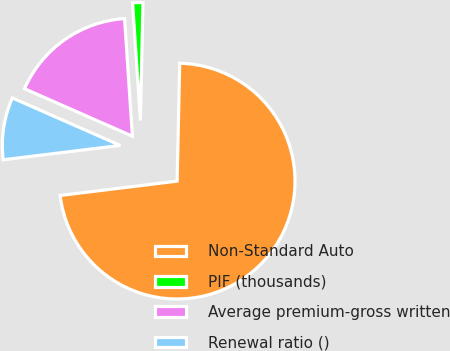Convert chart to OTSL. <chart><loc_0><loc_0><loc_500><loc_500><pie_chart><fcel>Non-Standard Auto<fcel>PIF (thousands)<fcel>Average premium-gross written<fcel>Renewal ratio ()<nl><fcel>72.7%<fcel>1.41%<fcel>17.34%<fcel>8.54%<nl></chart> 